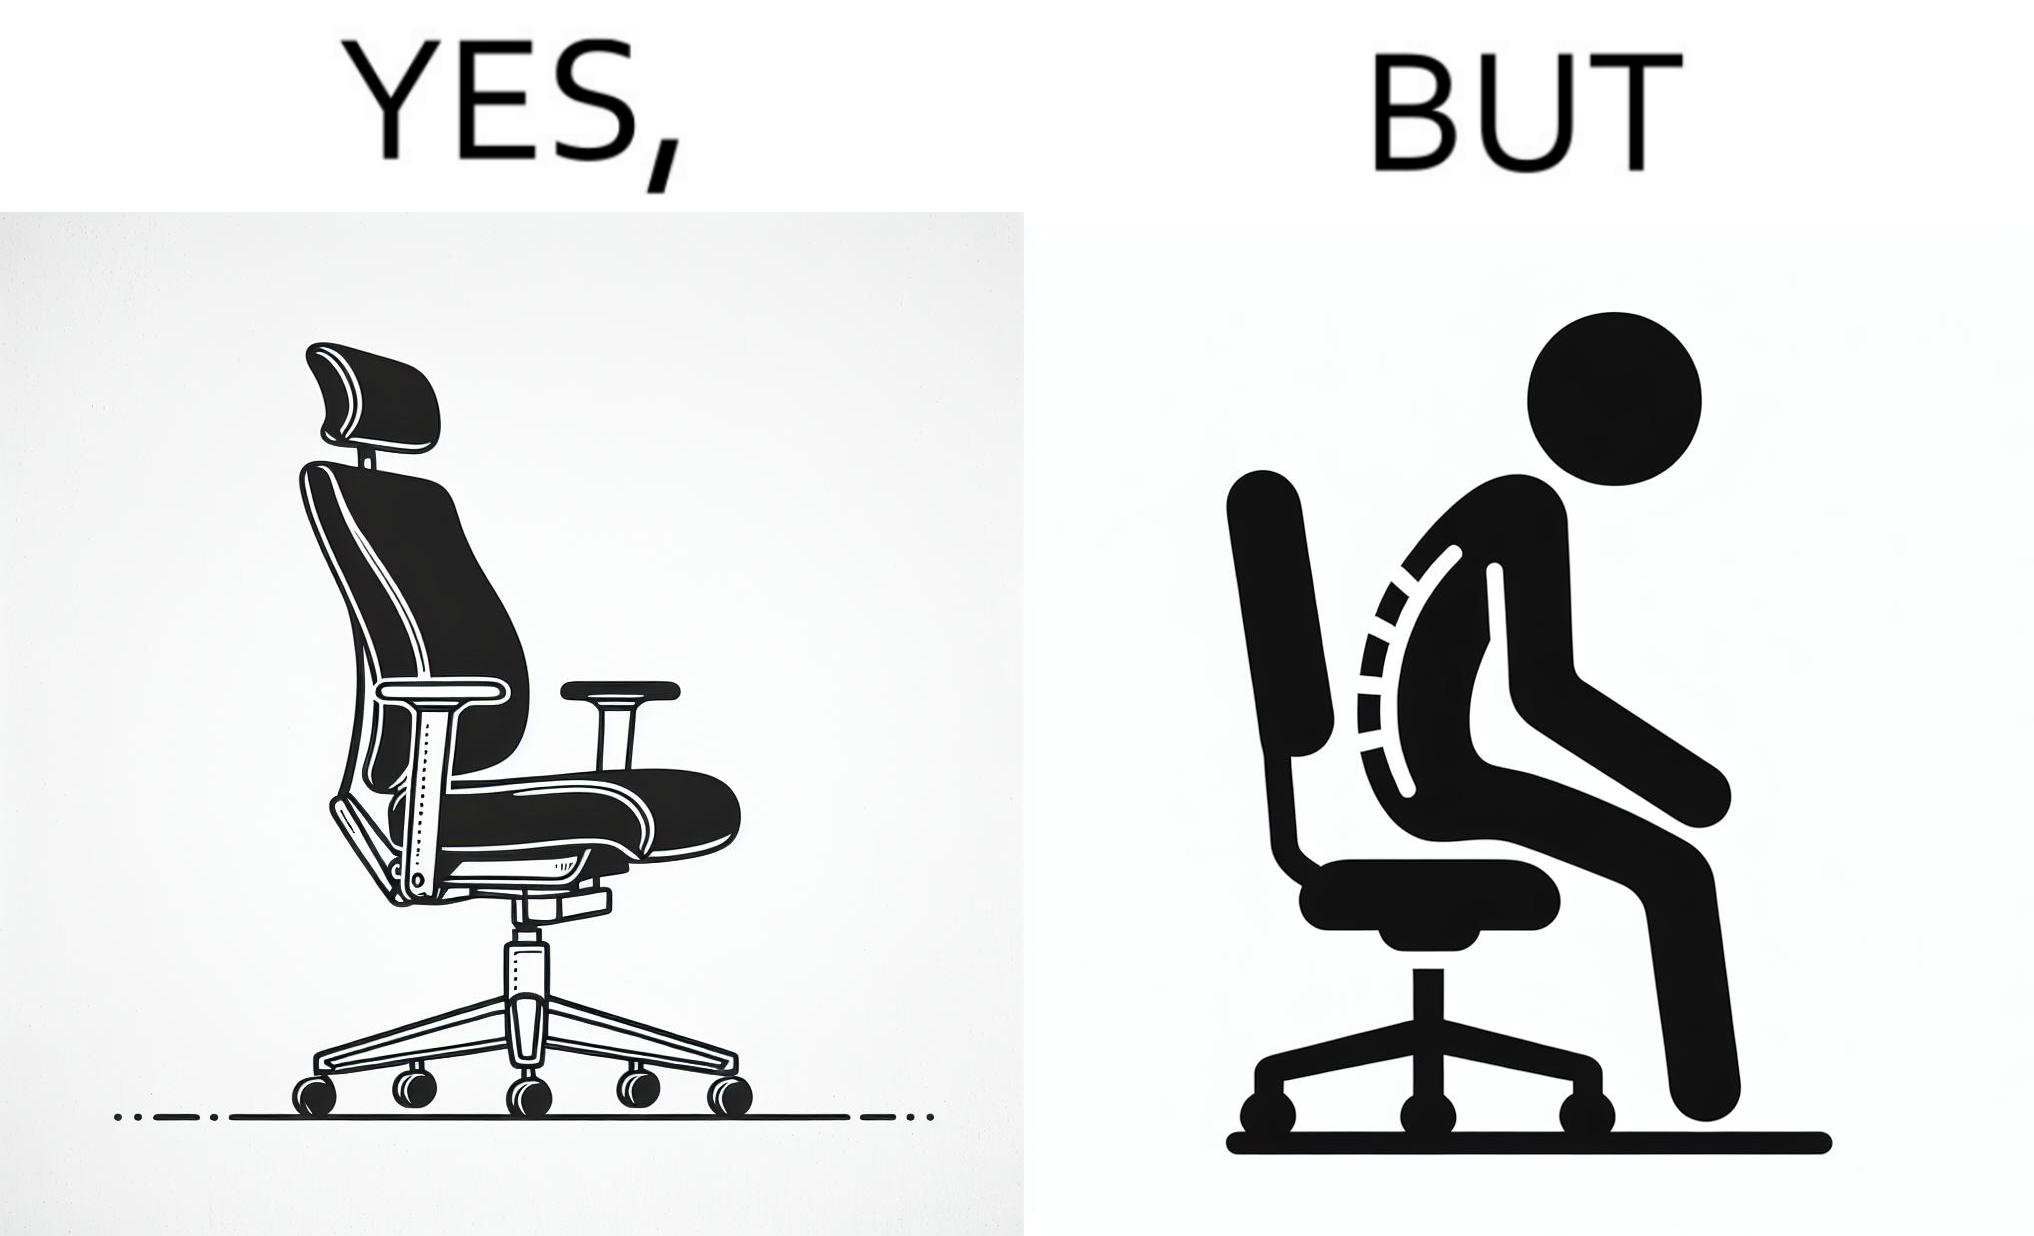Provide a description of this image. The image is ironical, as even though the ergonomic chair is meant to facilitate an upright and comfortable posture for the person sitting on it, the person sitting on it still has a bent posture, as the person is not utilizing the backrest. 